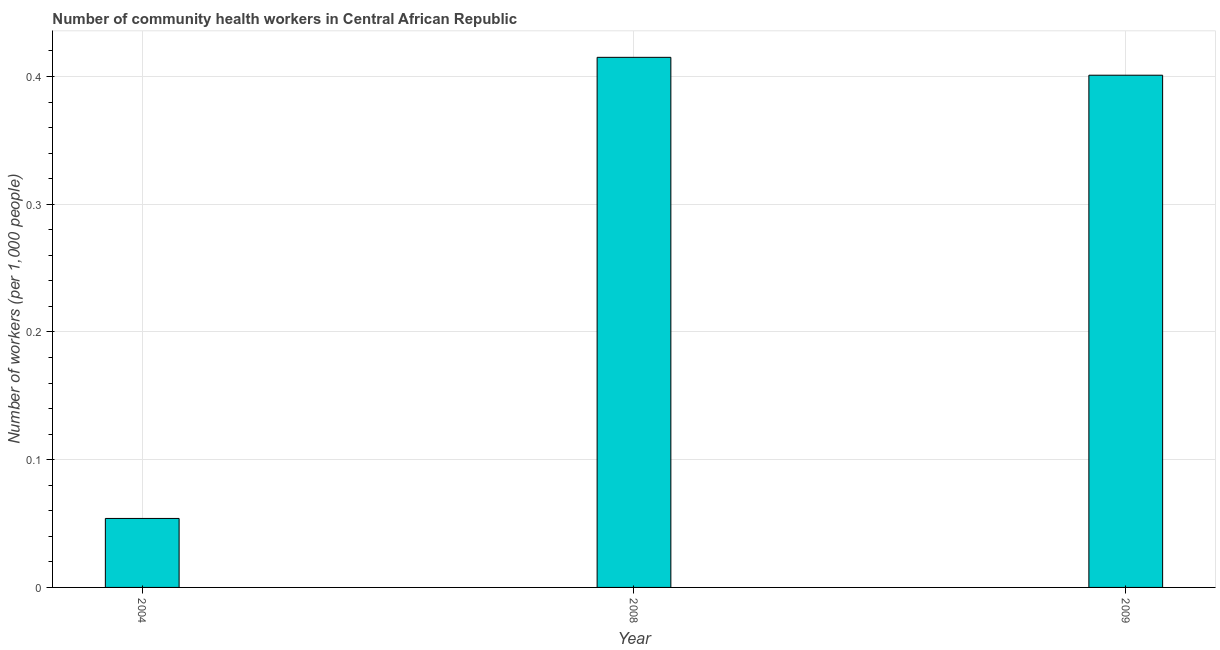Does the graph contain any zero values?
Offer a terse response. No. What is the title of the graph?
Ensure brevity in your answer.  Number of community health workers in Central African Republic. What is the label or title of the Y-axis?
Offer a very short reply. Number of workers (per 1,0 people). What is the number of community health workers in 2008?
Offer a terse response. 0.41. Across all years, what is the maximum number of community health workers?
Give a very brief answer. 0.41. Across all years, what is the minimum number of community health workers?
Give a very brief answer. 0.05. What is the sum of the number of community health workers?
Keep it short and to the point. 0.87. What is the difference between the number of community health workers in 2004 and 2009?
Ensure brevity in your answer.  -0.35. What is the average number of community health workers per year?
Your answer should be compact. 0.29. What is the median number of community health workers?
Ensure brevity in your answer.  0.4. In how many years, is the number of community health workers greater than 0.4 ?
Ensure brevity in your answer.  2. Do a majority of the years between 2009 and 2004 (inclusive) have number of community health workers greater than 0.36 ?
Your answer should be very brief. Yes. What is the ratio of the number of community health workers in 2004 to that in 2008?
Your response must be concise. 0.13. Is the number of community health workers in 2004 less than that in 2008?
Ensure brevity in your answer.  Yes. Is the difference between the number of community health workers in 2004 and 2008 greater than the difference between any two years?
Give a very brief answer. Yes. What is the difference between the highest and the second highest number of community health workers?
Provide a short and direct response. 0.01. What is the difference between the highest and the lowest number of community health workers?
Offer a terse response. 0.36. Are all the bars in the graph horizontal?
Keep it short and to the point. No. What is the difference between two consecutive major ticks on the Y-axis?
Ensure brevity in your answer.  0.1. Are the values on the major ticks of Y-axis written in scientific E-notation?
Your answer should be very brief. No. What is the Number of workers (per 1,000 people) of 2004?
Keep it short and to the point. 0.05. What is the Number of workers (per 1,000 people) in 2008?
Your answer should be compact. 0.41. What is the Number of workers (per 1,000 people) in 2009?
Make the answer very short. 0.4. What is the difference between the Number of workers (per 1,000 people) in 2004 and 2008?
Your answer should be compact. -0.36. What is the difference between the Number of workers (per 1,000 people) in 2004 and 2009?
Make the answer very short. -0.35. What is the difference between the Number of workers (per 1,000 people) in 2008 and 2009?
Provide a succinct answer. 0.01. What is the ratio of the Number of workers (per 1,000 people) in 2004 to that in 2008?
Offer a terse response. 0.13. What is the ratio of the Number of workers (per 1,000 people) in 2004 to that in 2009?
Make the answer very short. 0.14. What is the ratio of the Number of workers (per 1,000 people) in 2008 to that in 2009?
Ensure brevity in your answer.  1.03. 